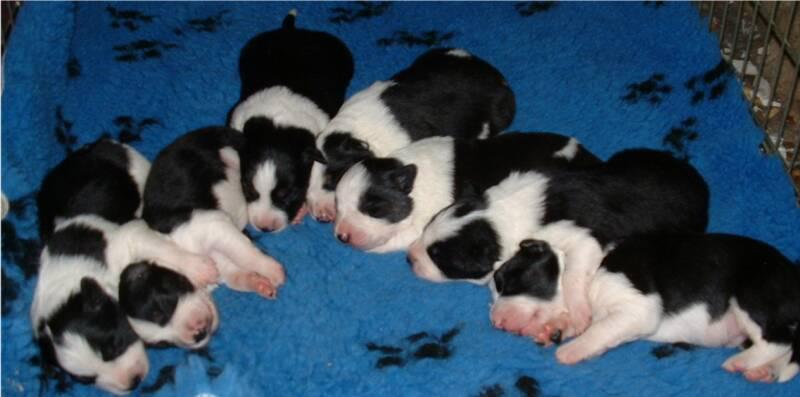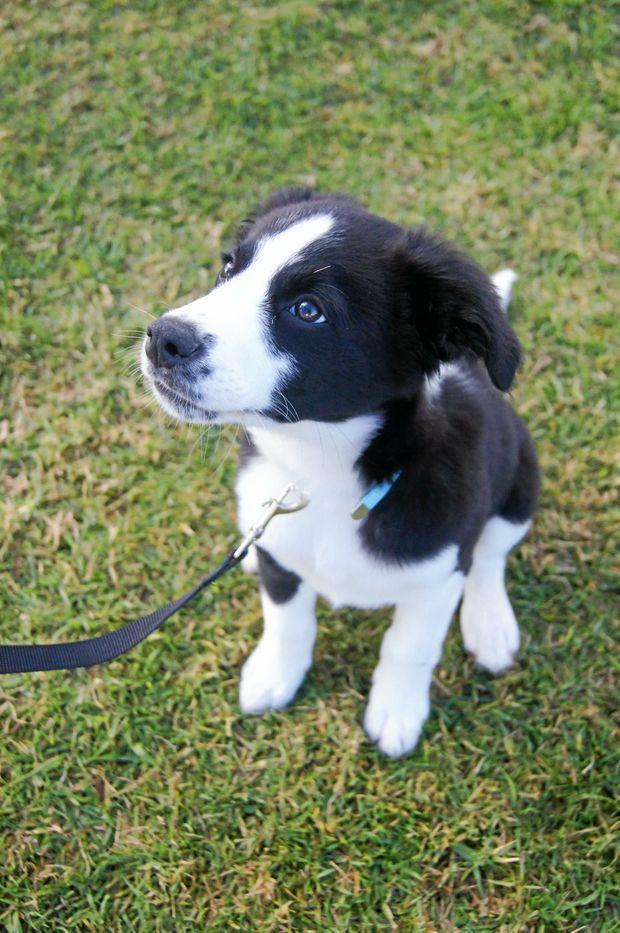The first image is the image on the left, the second image is the image on the right. Analyze the images presented: Is the assertion "An image contains a single black-and-white dog, which is sitting up and looking intently at something." valid? Answer yes or no. Yes. The first image is the image on the left, the second image is the image on the right. Examine the images to the left and right. Is the description "The right image contains at least three dogs." accurate? Answer yes or no. No. 